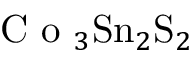<formula> <loc_0><loc_0><loc_500><loc_500>C o _ { 3 } S n _ { 2 } S _ { 2 }</formula> 